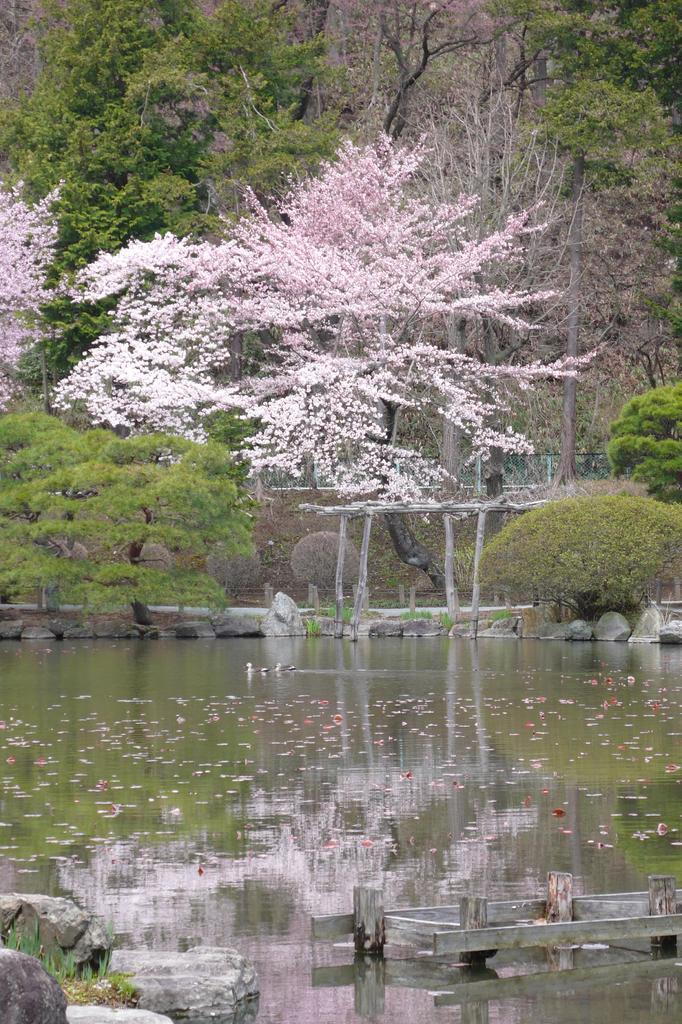Please provide a concise description of this image. In this image I can see the water. To the side of the water there are many rocks, wooden object and many trees. I can see these trees are in green, white and light pink color. 